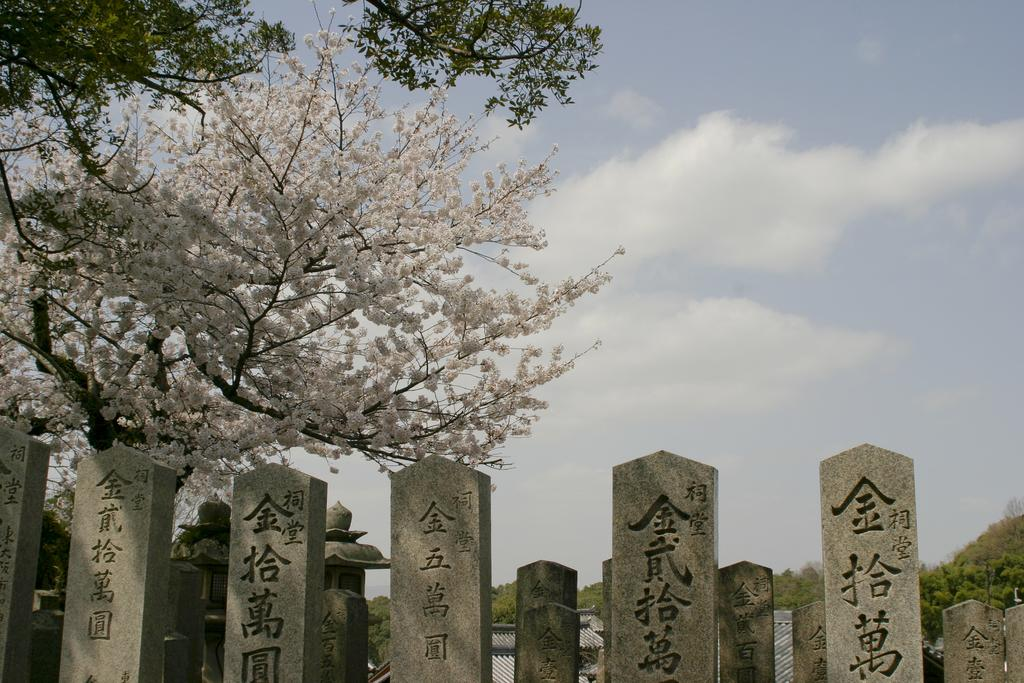What type of objects can be seen in the image? There are stones in the image. What is written on the stones? Something is written on the stones. What other natural elements are present in the image? There are trees in the image. What can be seen in the background of the image? The sky is visible in the background of the image. Can you see any wings on the trees in the image? There are no wings present on the trees in the image. What type of elbow is visible on the stones in the image? There are no elbows present on the stones in the image. 